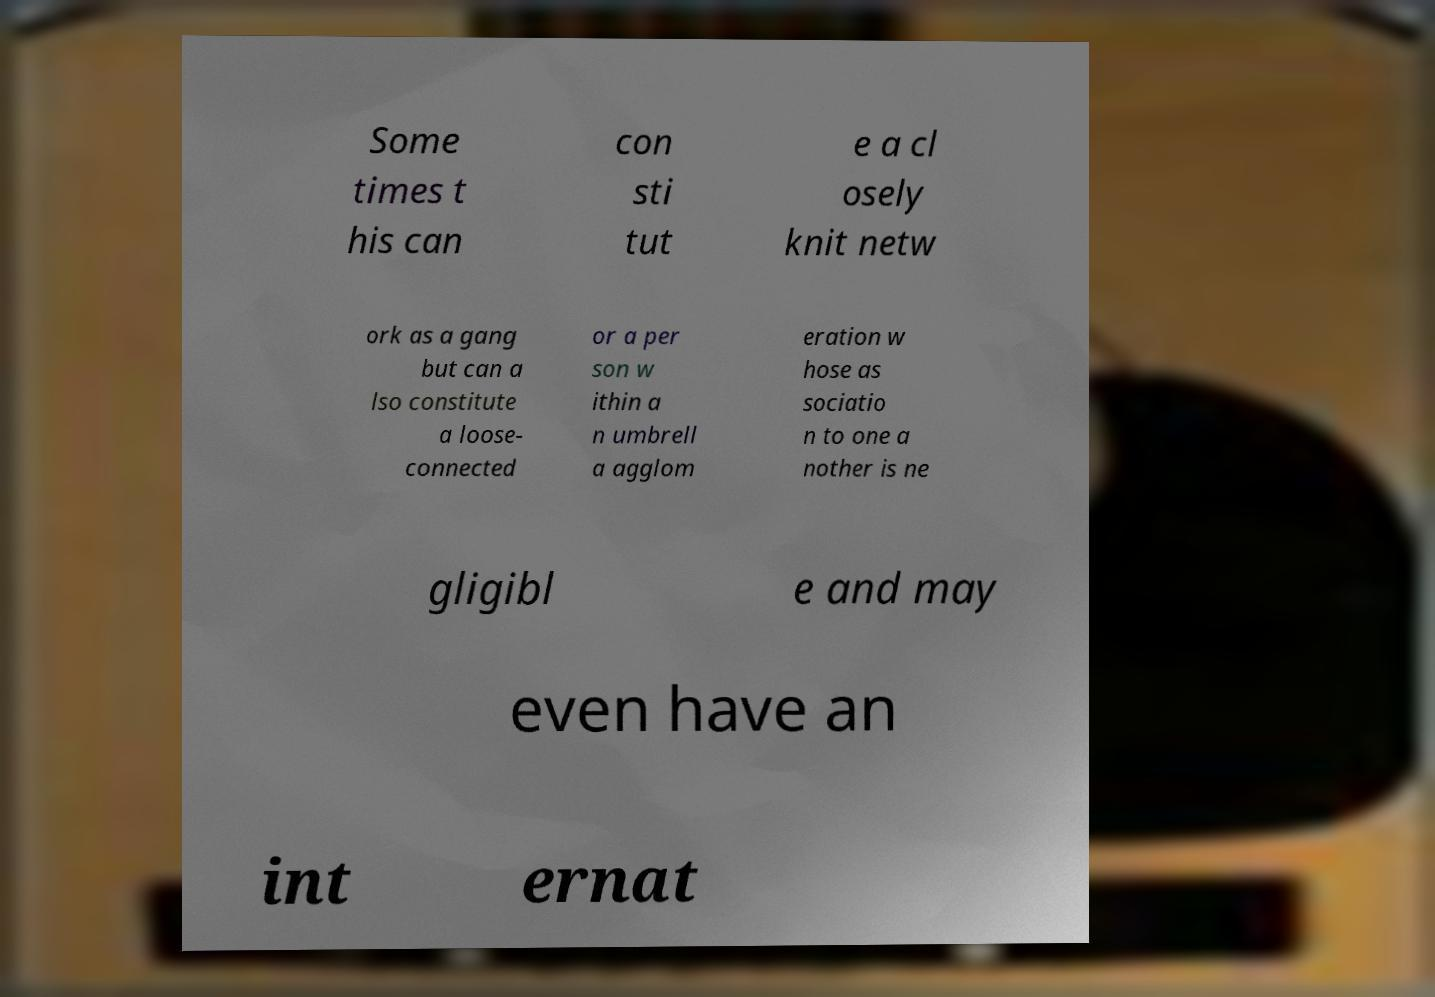What messages or text are displayed in this image? I need them in a readable, typed format. Some times t his can con sti tut e a cl osely knit netw ork as a gang but can a lso constitute a loose- connected or a per son w ithin a n umbrell a agglom eration w hose as sociatio n to one a nother is ne gligibl e and may even have an int ernat 